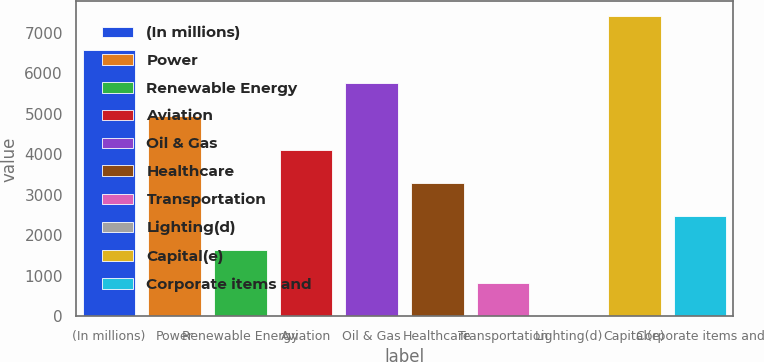Convert chart. <chart><loc_0><loc_0><loc_500><loc_500><bar_chart><fcel>(In millions)<fcel>Power<fcel>Renewable Energy<fcel>Aviation<fcel>Oil & Gas<fcel>Healthcare<fcel>Transportation<fcel>Lighting(d)<fcel>Capital(e)<fcel>Corporate items and<nl><fcel>6578.6<fcel>4934.2<fcel>1645.4<fcel>4112<fcel>5756.4<fcel>3289.8<fcel>823.2<fcel>1<fcel>7400.8<fcel>2467.6<nl></chart> 